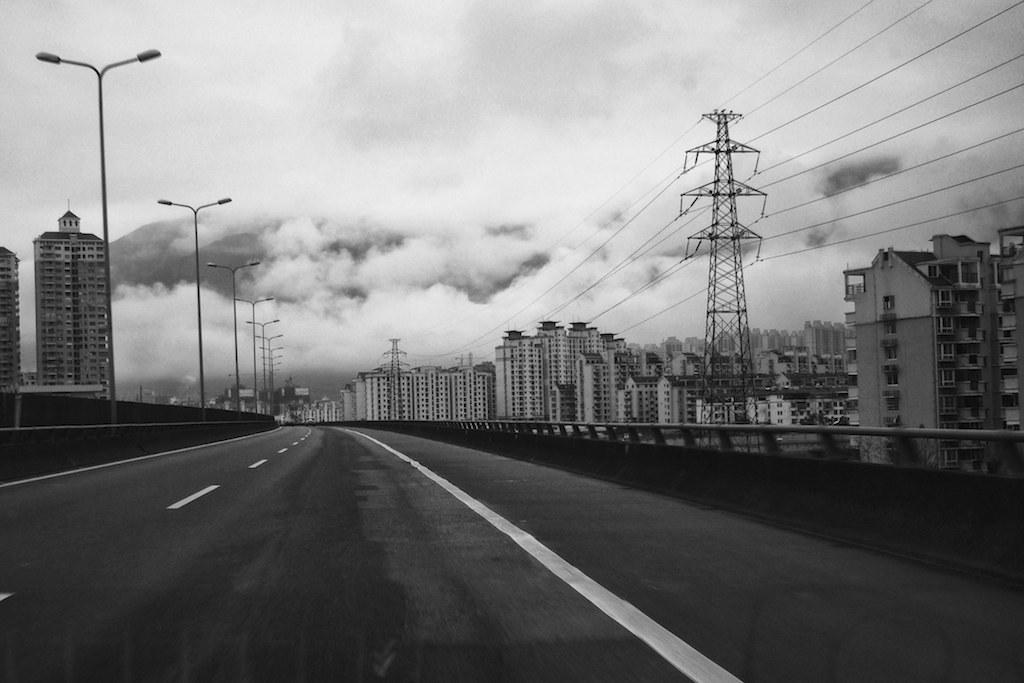What type of structure is in the image? There is a road bridge in the image. What can be seen behind the bridge? There are many white color buildings behind the bridge. What is attached to the metal pole in the image? There are cables on the metal pole in the image. Where are the street lights located in the image? The street lights are on the left side of the image. What type of rhythm does the daughter enjoy while folding the linen in the image? There is no daughter or linen present in the image, so it is not possible to answer that question. 